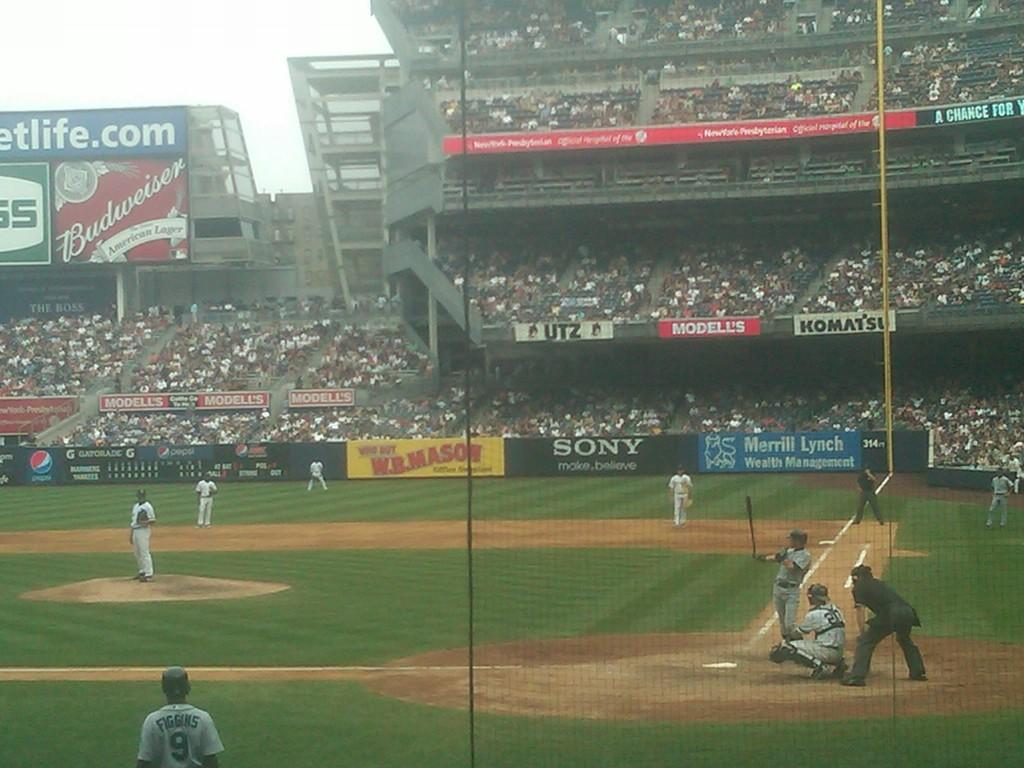Provide a one-sentence caption for the provided image. With a baseablle game ongoing the players are surrounded by advertising signs, one clear one being for SONY. 